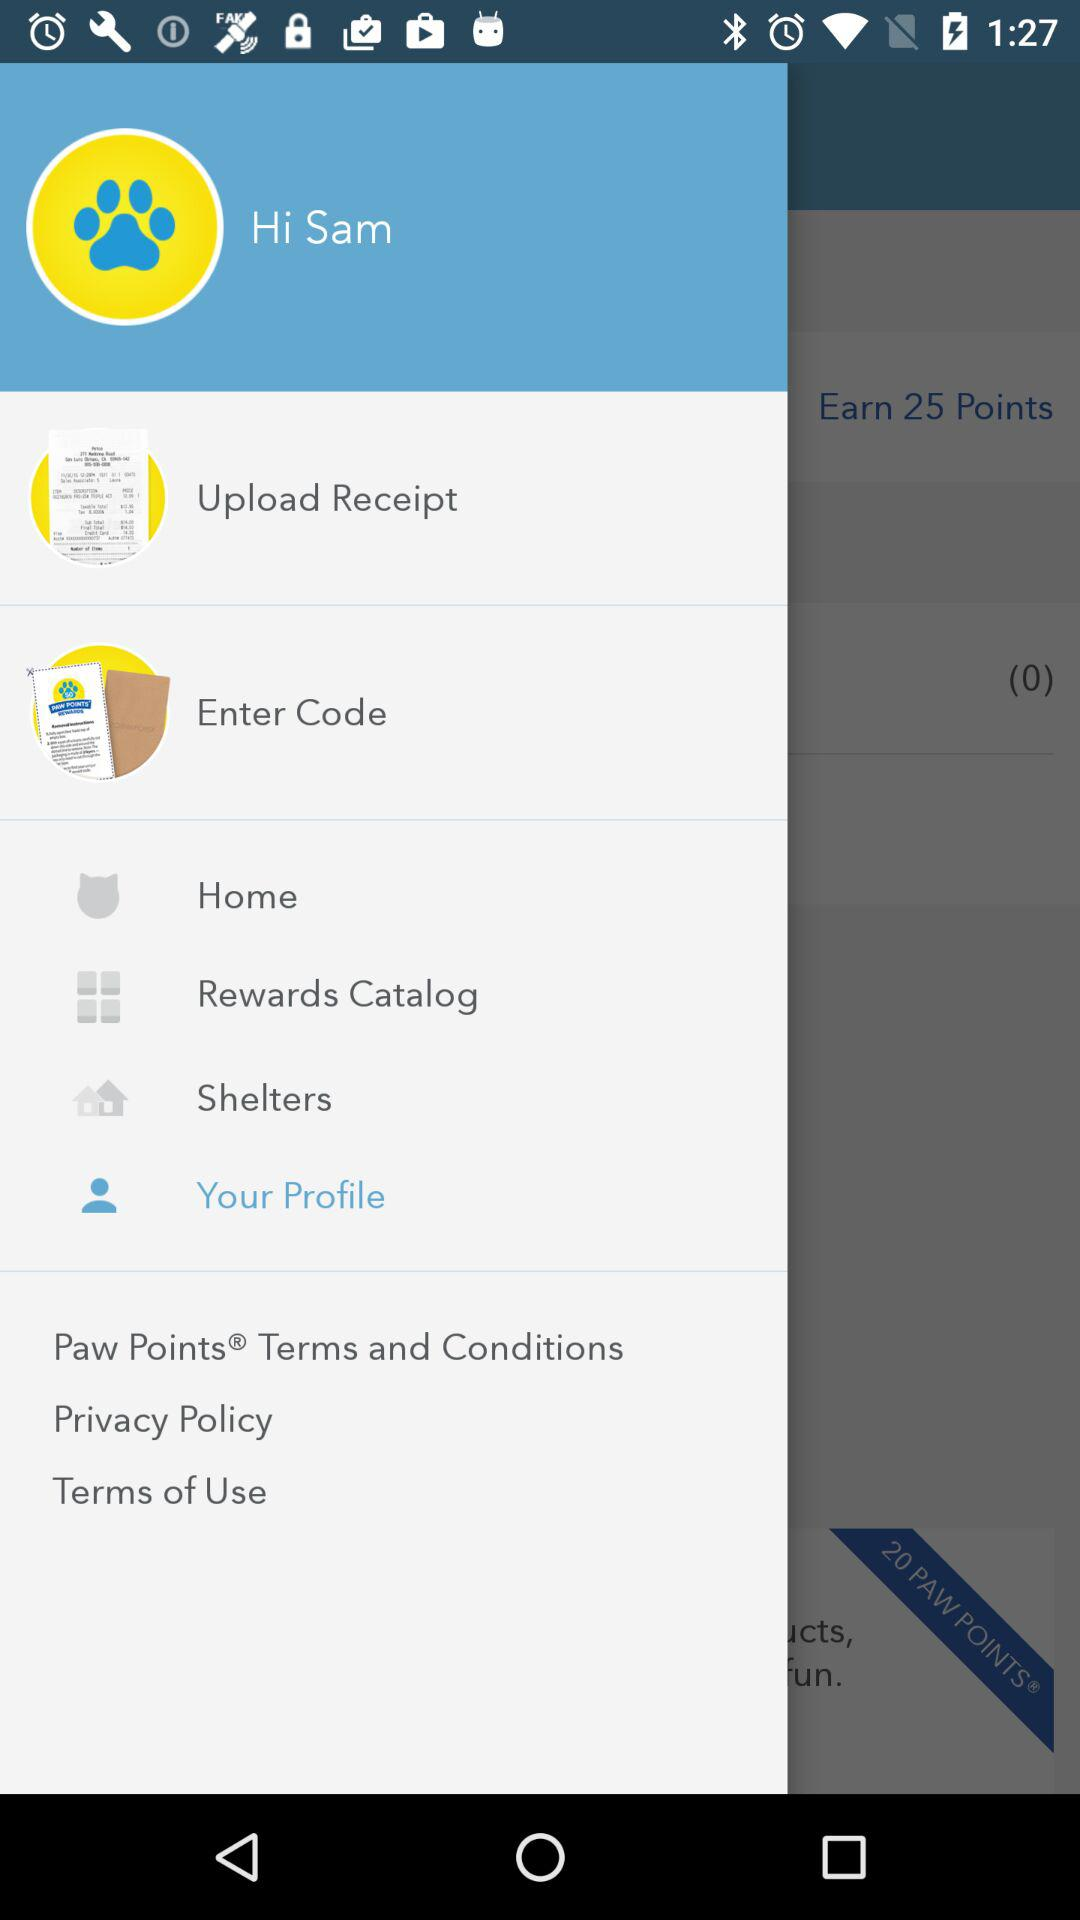How many points can be earned? There are 25 points that can be earned. 